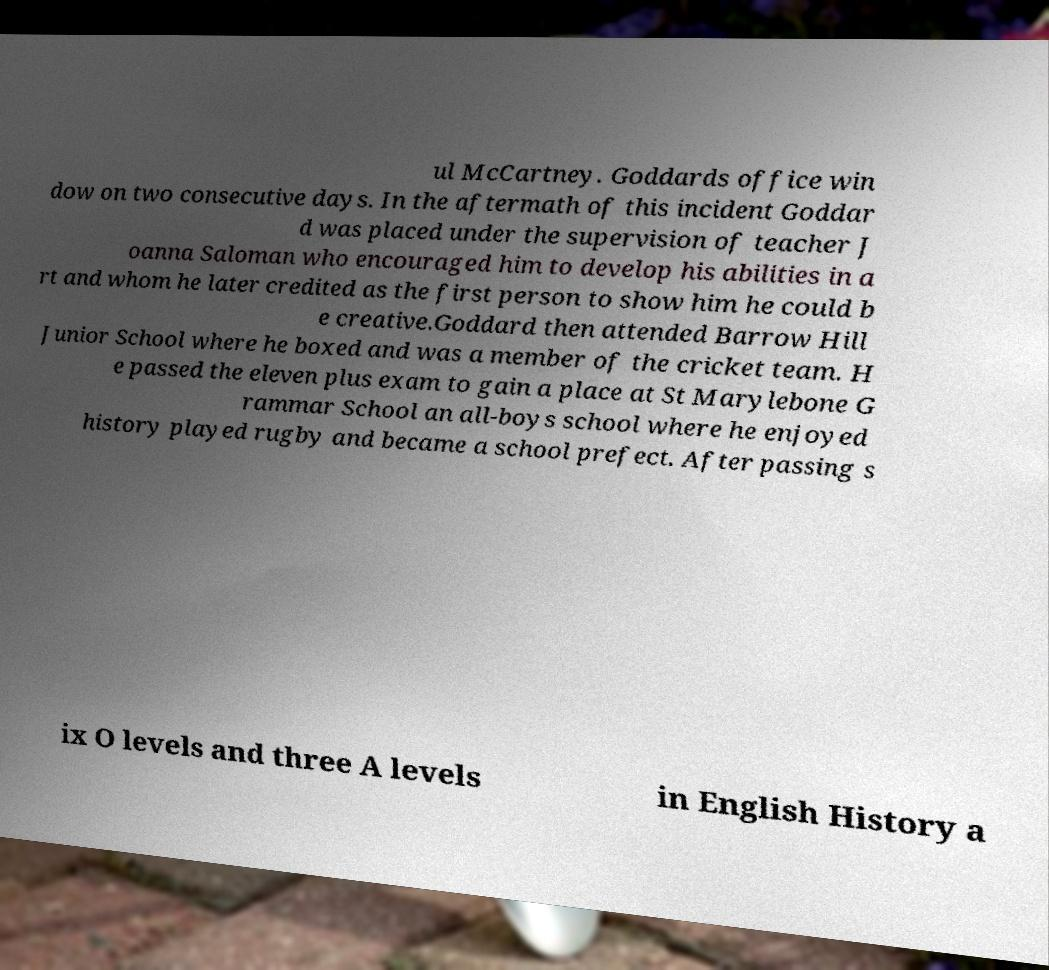There's text embedded in this image that I need extracted. Can you transcribe it verbatim? ul McCartney. Goddards office win dow on two consecutive days. In the aftermath of this incident Goddar d was placed under the supervision of teacher J oanna Saloman who encouraged him to develop his abilities in a rt and whom he later credited as the first person to show him he could b e creative.Goddard then attended Barrow Hill Junior School where he boxed and was a member of the cricket team. H e passed the eleven plus exam to gain a place at St Marylebone G rammar School an all-boys school where he enjoyed history played rugby and became a school prefect. After passing s ix O levels and three A levels in English History a 